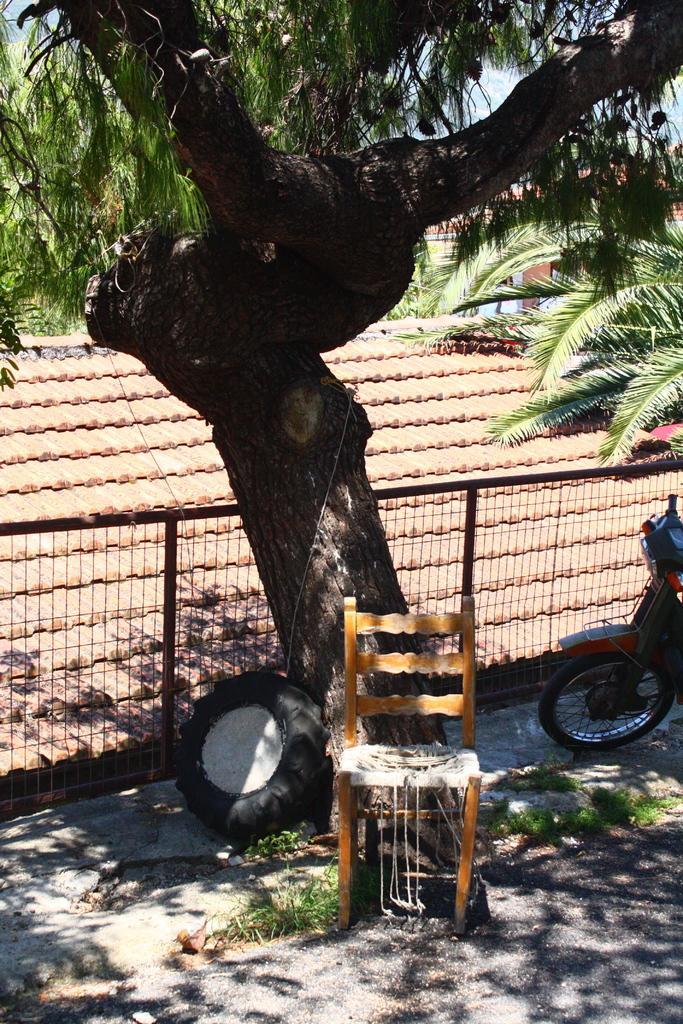Please provide a concise description of this image. This picture is taken outside the house. In the center of the image there is a tree. In the center of the image there is a chair and a tyre also. On the left there is a vehicle. In the center of the image there is railing. In the background there are houses and trees. Sky is clear. 